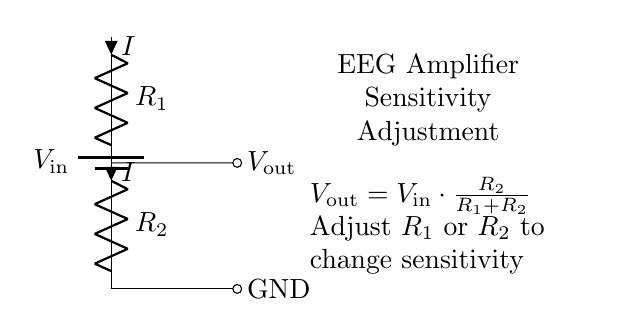What are the resistors in this circuit? The circuit shows two resistors, labeled R1 and R2, indicating that they are components within the voltage divider network.
Answer: R1, R2 What is the relationship between input voltage and output voltage? The output voltage, Vout, is calculated using the formula Vout = Vin * (R2 / (R1 + R2)), showing that it is directly proportional to the ratio of R2 to the total resistance.
Answer: Vout = Vin * (R2 / (R1 + R2)) What is the purpose of adjusting R1 or R2? Adjusting R1 or R2 changes the sensitivity of the EEG amplifier, which affects how the amplifier interprets the input signals from the EEG electrodes.
Answer: Change sensitivity What is the current flowing through R1 and R2? The current i flowing through both resistors R1 and R2 is the same, as they are in series in a voltage divider configuration.
Answer: I How does increasing R1 affect Vout? Increasing R1 results in a higher total resistance (R1 + R2), which lowers the output voltage (Vout) according to the voltage divider formula, thus decreasing the sensitivity.
Answer: Decreases Vout What will happen if R2 is set to a very low value? Setting R2 to a very low value minimizes its resistance, leading to Vout approaching zero, which indicates low sensitivity in the EEG amplifier.
Answer: Vout approaches zero 